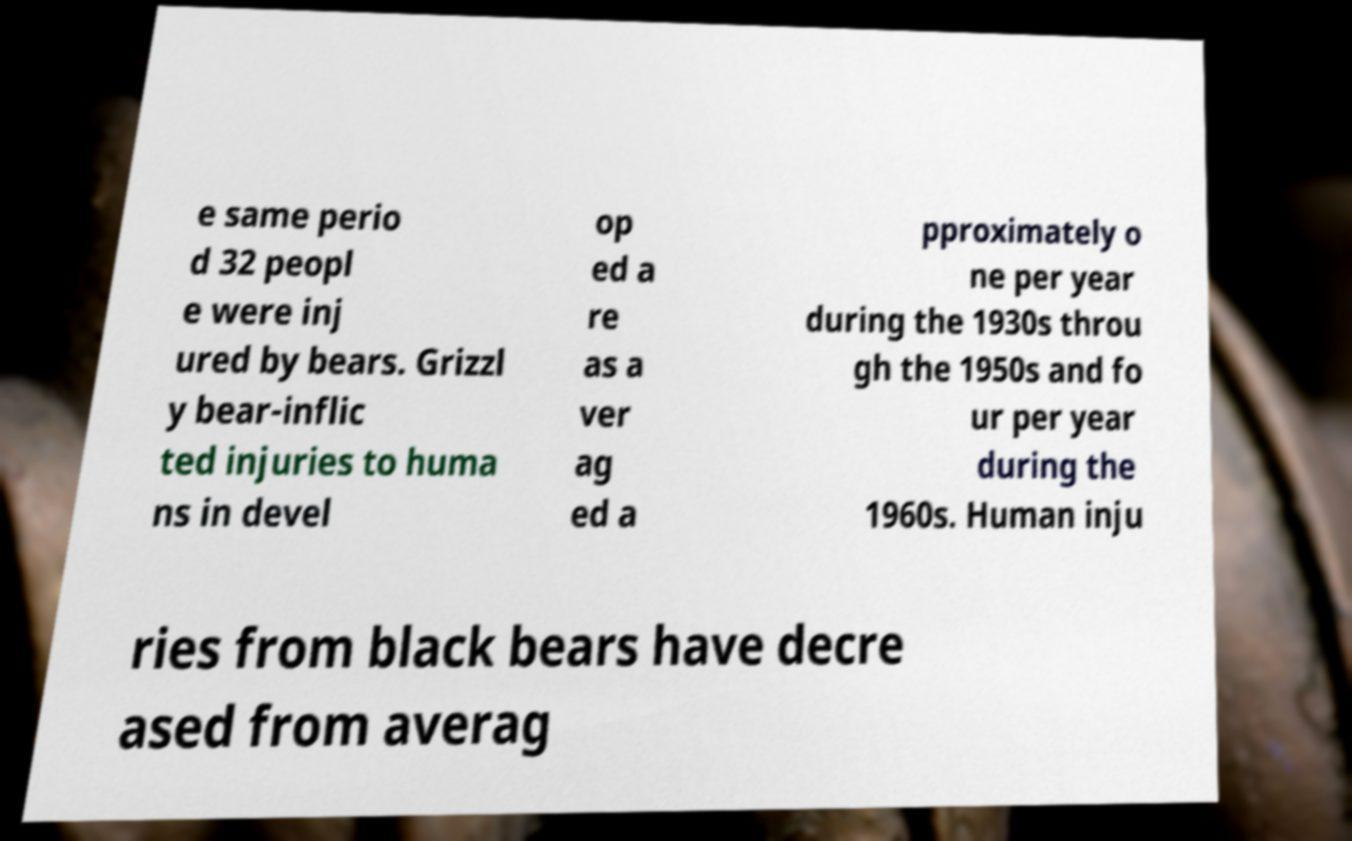What messages or text are displayed in this image? I need them in a readable, typed format. e same perio d 32 peopl e were inj ured by bears. Grizzl y bear-inflic ted injuries to huma ns in devel op ed a re as a ver ag ed a pproximately o ne per year during the 1930s throu gh the 1950s and fo ur per year during the 1960s. Human inju ries from black bears have decre ased from averag 